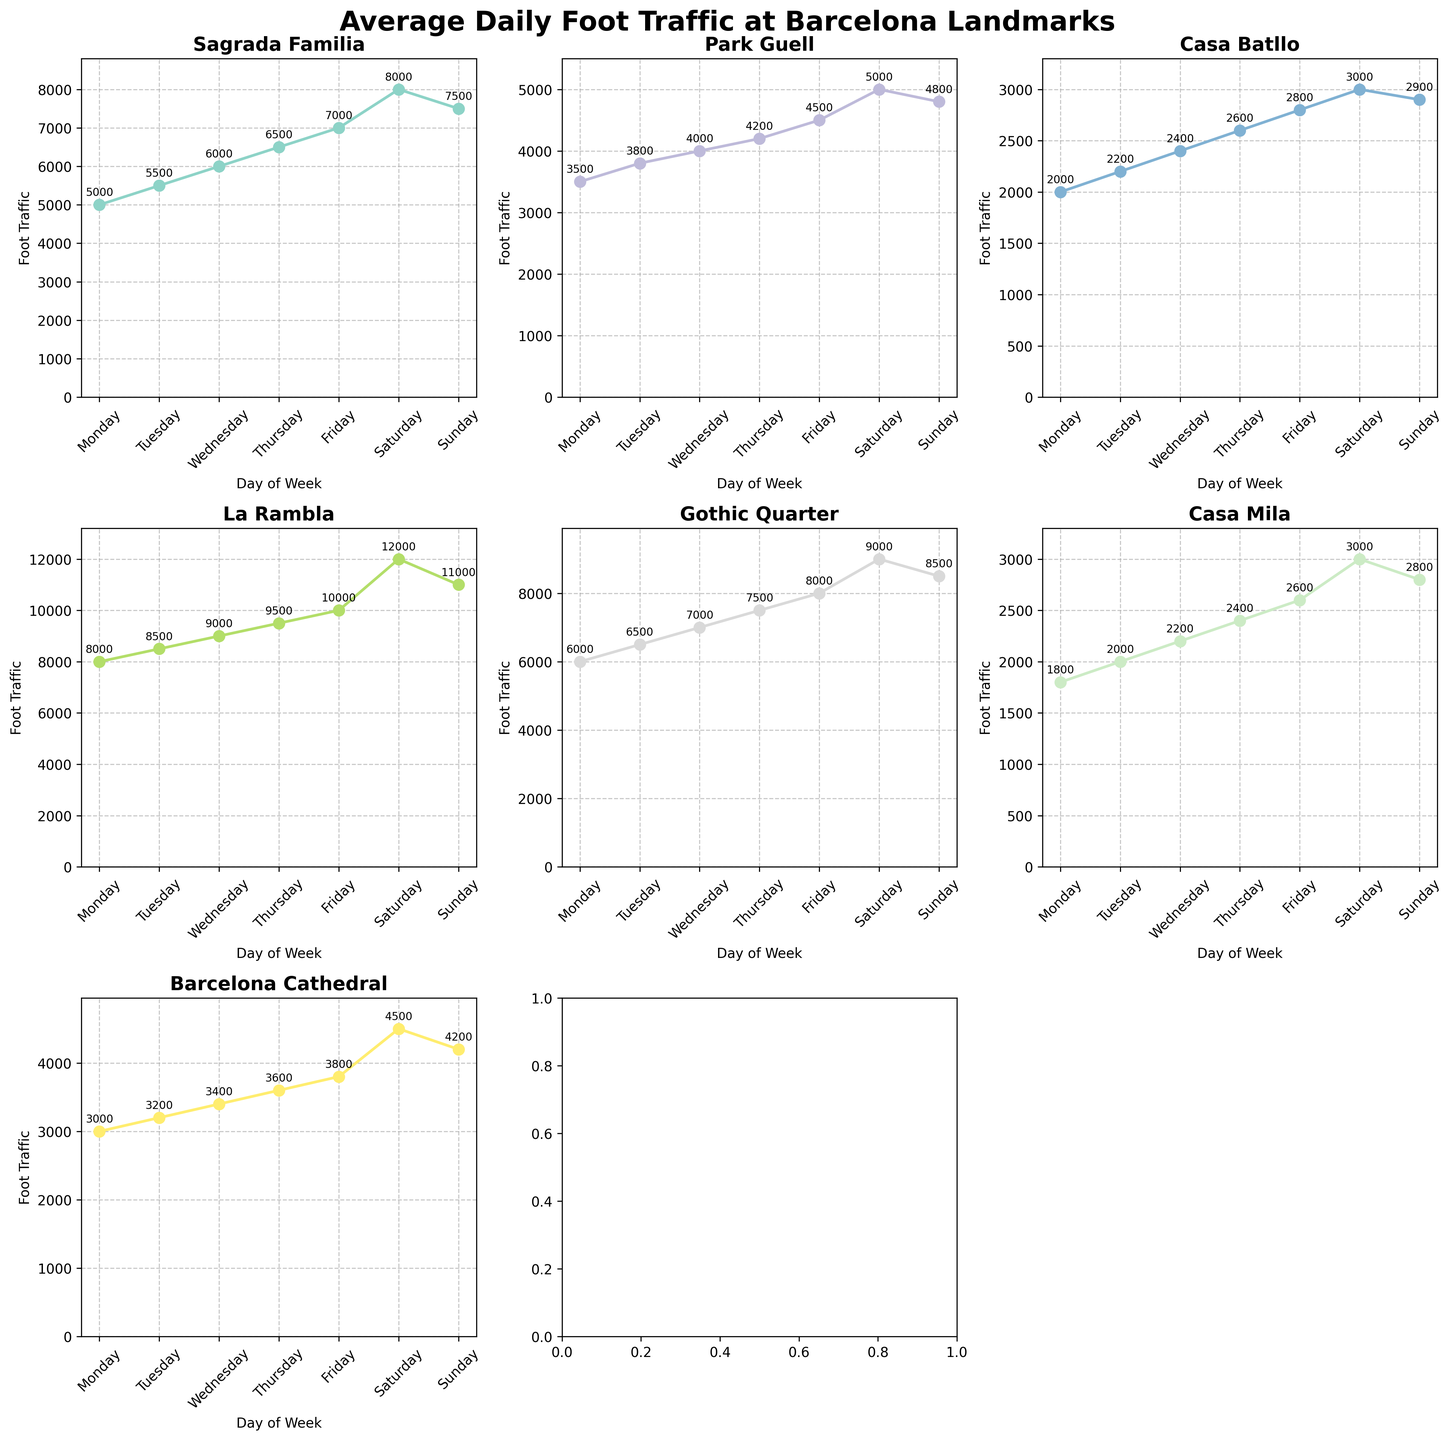What's the title of the figure? The title of the figure is displayed at the top of the image, providing an overview of what the figure shows.
Answer: Average Daily Foot Traffic at Barcelona Landmarks Which landmark shows the highest foot traffic on Saturday? Locate the subplot for each landmark, then find the Saturday data point. Compare all to determine the highest value.
Answer: La Rambla What is the difference in foot traffic at Sagrada Familia between Monday and Friday? Identify the data points for Sagrada Familia on Monday (5000) and Friday (7000). Subtract Monday's value from Friday's value: 7000 - 5000.
Answer: 2000 Which days see the least visitors to Park Guell and Casa Batllo? Find the minimum foot traffic value in the subplots for Park Guell and Casa Batllo. Identify the corresponding day for each minimum value.
Answer: Monday for both Which landmark experiences the most consistent foot traffic throughout the week? Examine the subplots for each landmark. Look for the plot with the smallest range (difference between maximum and minimum values).
Answer: Casa Mila What is the average foot traffic on Thursday at the Gothic Quarter and Barcelona Cathedral combined? Locate the data points for Thursday: Gothic Quarter (7500), Barcelona Cathedral (3600). Sum these values and divide by 2. (7500 + 3600) / 2 = 5550.
Answer: 5550 On which day does Casa Mila receive the lowest foot traffic? Identify the data points for Casa Mila, look for the smallest value and the corresponding day.
Answer: Monday Between Wednesday and Sunday, which landmark has the greatest increase in foot traffic? Calculate the increase for each landmark between Wednesday and Sunday. Identify the landmark with the largest difference.
Answer: La Rambla What's the overall range of foot traffic for La Rambla within the week? Find the maximum and minimum data points for La Rambla: Max (Saturday, 12000) and Min (Monday, 8000). Subtract to find the range: 12000 - 8000.
Answer: 4000 Which three days have the highest foot traffic for the Barcelona Cathedral? Identify the highest three data points for the Barcelona Cathedral subplot and their respective days.
Answer: Saturday, Sunday, Friday 